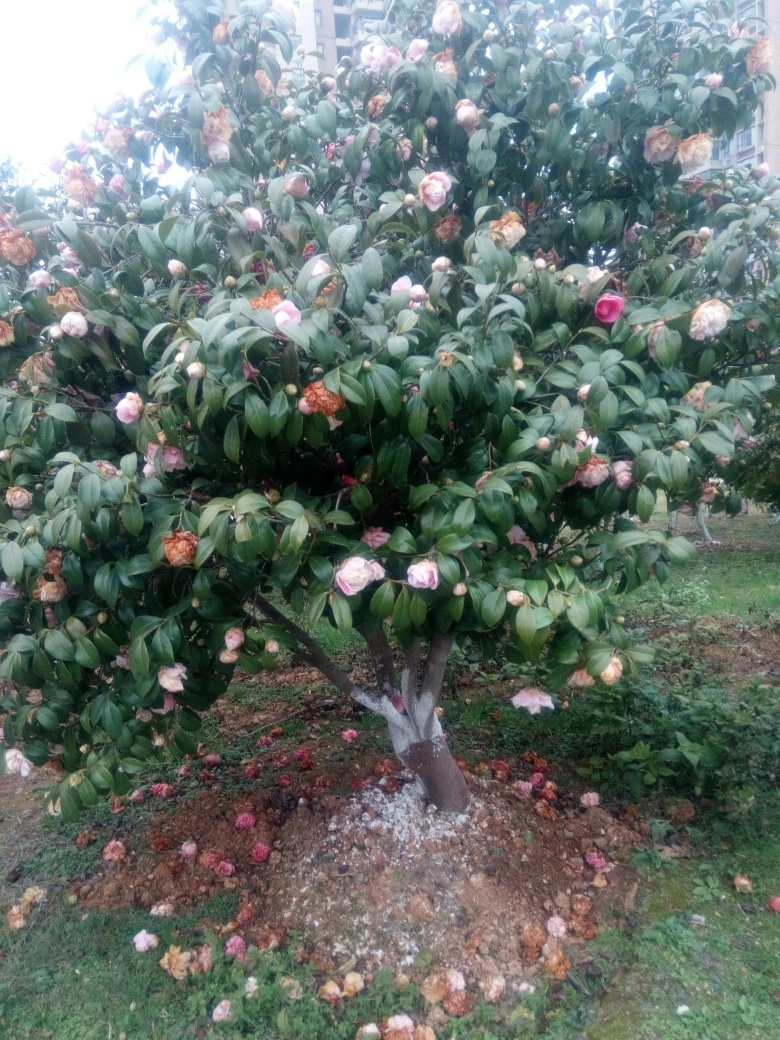What is the condition of the flowers shown in this image? The condition of the flowers varies; some are in full bloom with vibrant colors, whereas others are in various stages of decay. The mix of blooming and wilted flowers suggests the image captures the natural cycle of the tree's flowering period. 